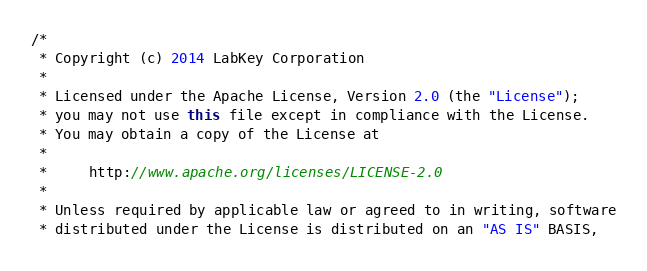Convert code to text. <code><loc_0><loc_0><loc_500><loc_500><_Java_>/*
 * Copyright (c) 2014 LabKey Corporation
 *
 * Licensed under the Apache License, Version 2.0 (the "License");
 * you may not use this file except in compliance with the License.
 * You may obtain a copy of the License at
 *
 *     http://www.apache.org/licenses/LICENSE-2.0
 *
 * Unless required by applicable law or agreed to in writing, software
 * distributed under the License is distributed on an "AS IS" BASIS,</code> 